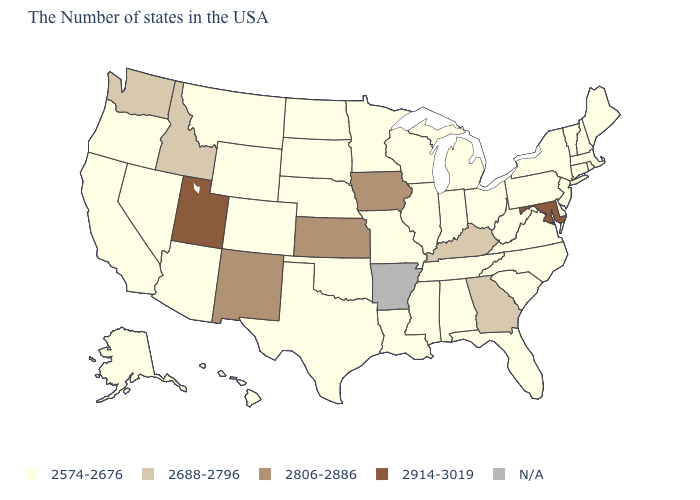Does the map have missing data?
Give a very brief answer. Yes. Name the states that have a value in the range 2574-2676?
Keep it brief. Maine, Massachusetts, Rhode Island, New Hampshire, Vermont, Connecticut, New York, New Jersey, Delaware, Pennsylvania, Virginia, North Carolina, South Carolina, West Virginia, Ohio, Florida, Michigan, Indiana, Alabama, Tennessee, Wisconsin, Illinois, Mississippi, Louisiana, Missouri, Minnesota, Nebraska, Oklahoma, Texas, South Dakota, North Dakota, Wyoming, Colorado, Montana, Arizona, Nevada, California, Oregon, Alaska, Hawaii. What is the value of West Virginia?
Answer briefly. 2574-2676. What is the value of Arizona?
Answer briefly. 2574-2676. What is the lowest value in the USA?
Give a very brief answer. 2574-2676. Is the legend a continuous bar?
Answer briefly. No. What is the highest value in the USA?
Be succinct. 2914-3019. What is the value of Connecticut?
Keep it brief. 2574-2676. Name the states that have a value in the range N/A?
Be succinct. Arkansas. Which states hav the highest value in the MidWest?
Keep it brief. Iowa, Kansas. What is the lowest value in the Northeast?
Concise answer only. 2574-2676. Among the states that border South Dakota , which have the highest value?
Keep it brief. Iowa. 